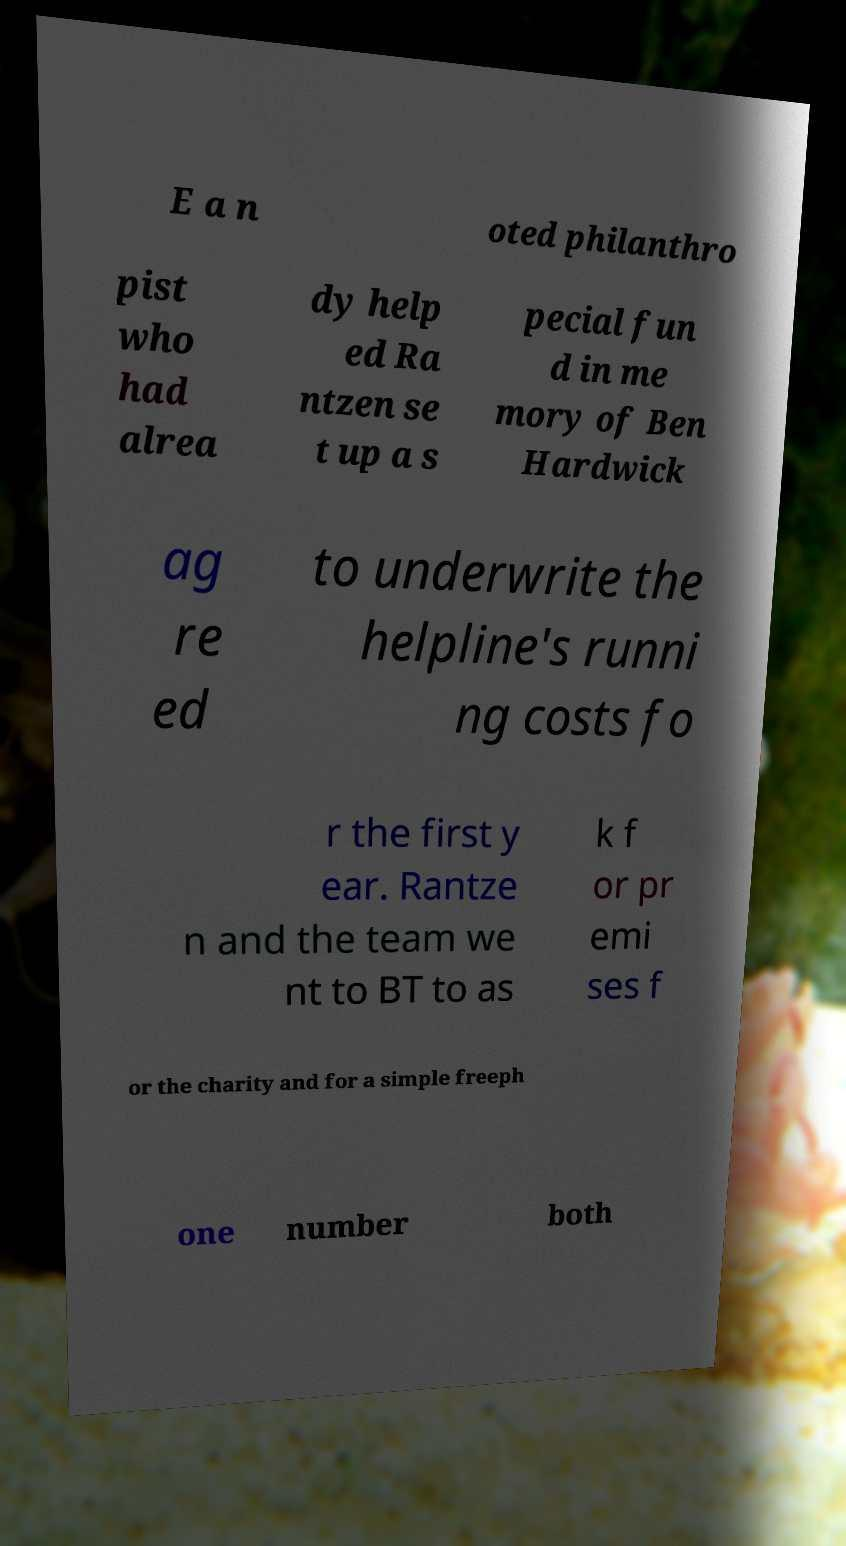Could you extract and type out the text from this image? E a n oted philanthro pist who had alrea dy help ed Ra ntzen se t up a s pecial fun d in me mory of Ben Hardwick ag re ed to underwrite the helpline's runni ng costs fo r the first y ear. Rantze n and the team we nt to BT to as k f or pr emi ses f or the charity and for a simple freeph one number both 